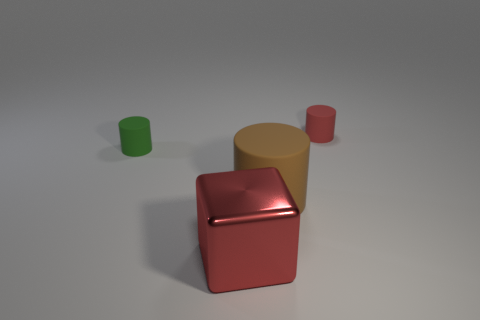Can you describe the lighting and shadows in the scene? The lighting in the image seems to come from above, creating soft shadows that trail away from the objects. The shadows are not overly pronounced, indicating the light source is not extremely bright and is diffused somewhat, possibly by an overcast sky or softbox used in photography. 